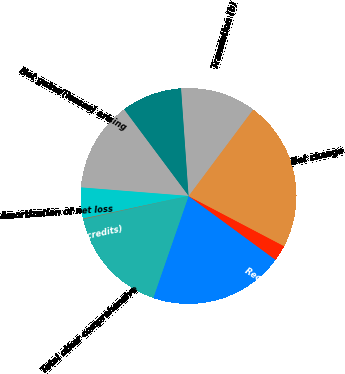Convert chart to OTSL. <chart><loc_0><loc_0><loc_500><loc_500><pie_chart><fcel>Net unrealized gains/(losses)<fcel>Reclassification adjustment<fcel>Net change<fcel>Translation (b)<fcel>Hedges (b)<fcel>Net gains/(losses) arising<fcel>Amortization of net loss<fcel>Prior service costs/(credits)<fcel>Total other comprehensive<nl><fcel>20.23%<fcel>2.38%<fcel>22.49%<fcel>11.32%<fcel>9.08%<fcel>13.55%<fcel>4.61%<fcel>0.15%<fcel>16.2%<nl></chart> 